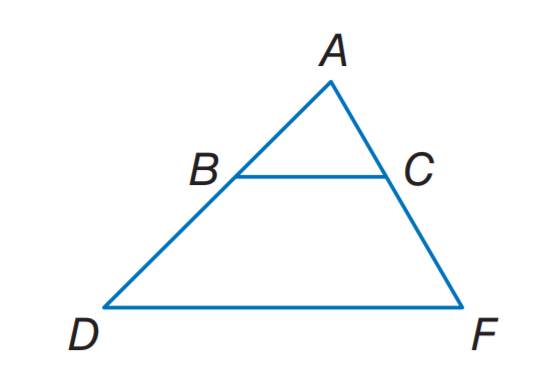Question: B C \parallel D F. A C = 15, B D = 3 x - 2, C F = 3 x + 2, and A B = 12. Find x.
Choices:
A. 3
B. 4
C. 5
D. 6
Answer with the letter. Answer: D Question: B C \parallel D F. A B = x + 5, B D = 12, A C = 3 x + 1, and C F = 15. Find x.
Choices:
A. 3
B. 4
C. 5
D. 6
Answer with the letter. Answer: A 